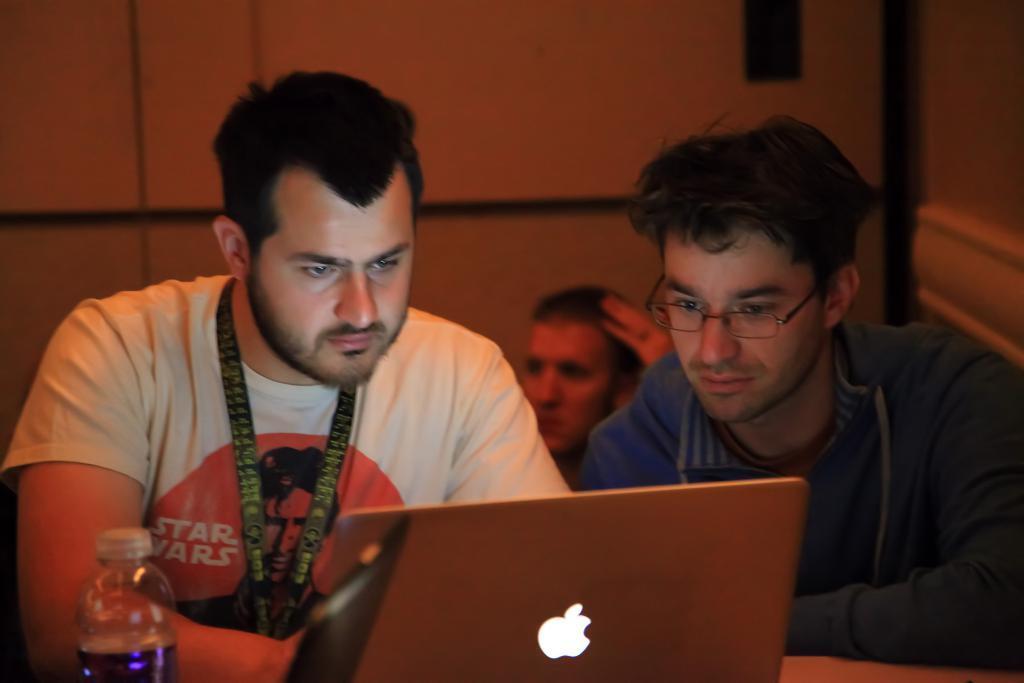Please provide a concise description of this image. In this image, 3 peoples are there. Few are seeing a laptop. There is an another laptop at the bottom, bottle. Back Side, we can see a wall. 